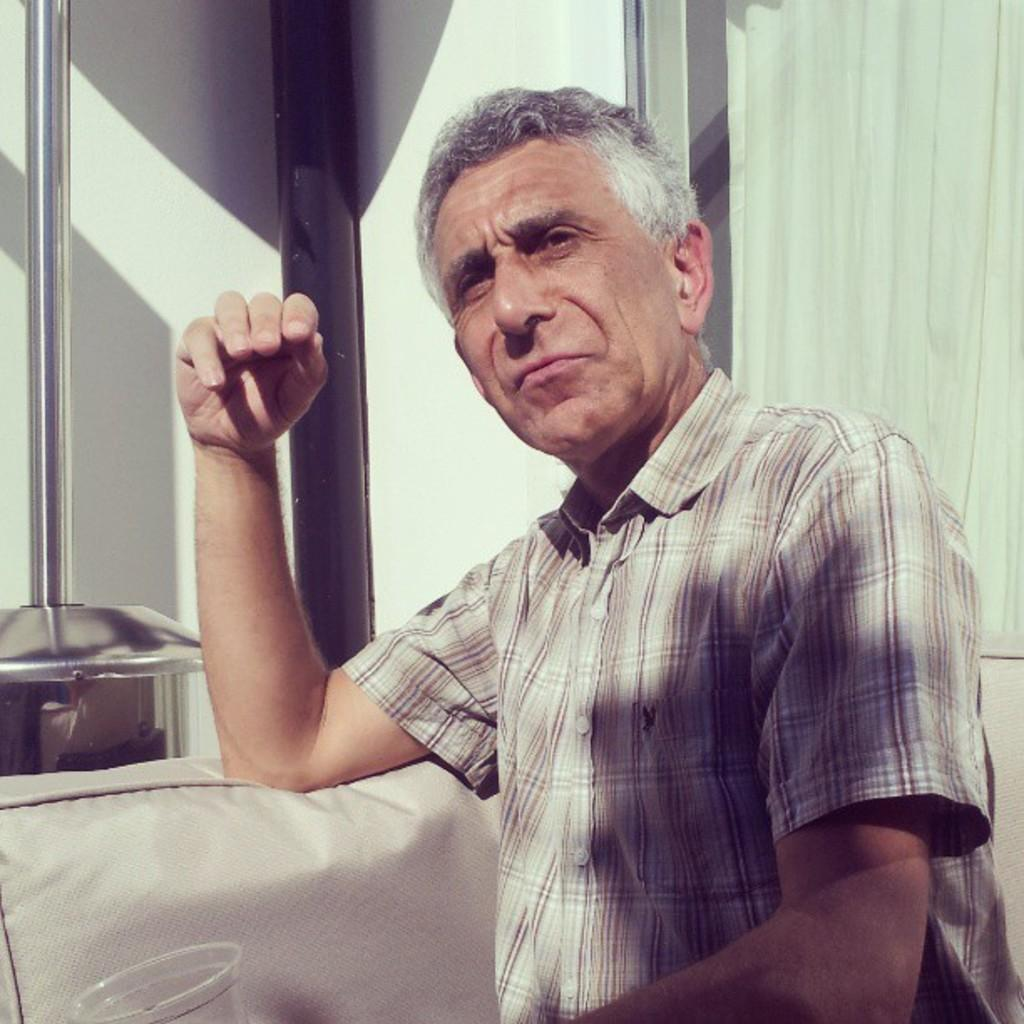What is the color of the wall in the image? The wall in the image is white. What type of window treatment is present in the image? There is a curtain in the image. What piece of furniture is in the image? There is a bed in the image. Who or what is in the front of the image? There is a person in the front of the image. What is located on the left side of the image? There is a glass on the left side of the image. What is the person in the image reading, a prose or a grain? There is no indication in the image that the person is reading anything, and therefore we cannot determine if it is prose or grain. 